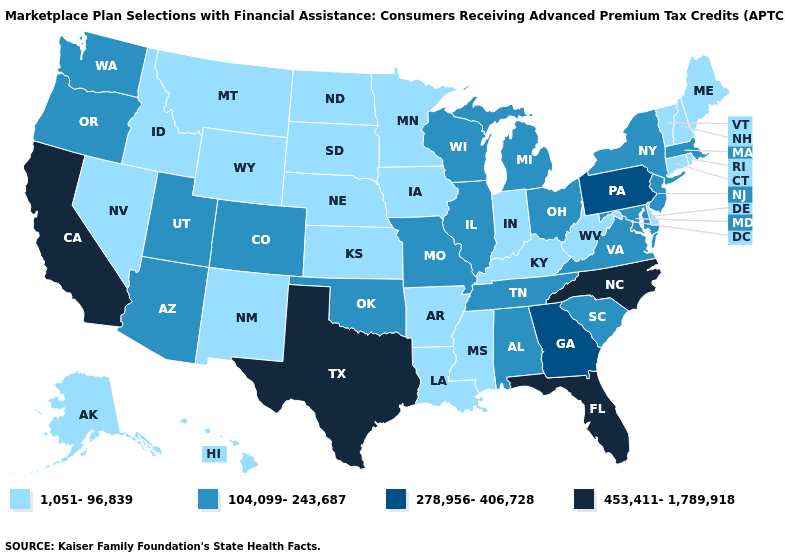What is the value of New York?
Write a very short answer. 104,099-243,687. Does Illinois have the lowest value in the MidWest?
Keep it brief. No. Does Minnesota have a lower value than North Carolina?
Write a very short answer. Yes. What is the highest value in the USA?
Keep it brief. 453,411-1,789,918. Name the states that have a value in the range 453,411-1,789,918?
Write a very short answer. California, Florida, North Carolina, Texas. Does Alabama have the lowest value in the USA?
Keep it brief. No. Does Virginia have the same value as Alabama?
Write a very short answer. Yes. Does Colorado have the highest value in the USA?
Give a very brief answer. No. Name the states that have a value in the range 1,051-96,839?
Concise answer only. Alaska, Arkansas, Connecticut, Delaware, Hawaii, Idaho, Indiana, Iowa, Kansas, Kentucky, Louisiana, Maine, Minnesota, Mississippi, Montana, Nebraska, Nevada, New Hampshire, New Mexico, North Dakota, Rhode Island, South Dakota, Vermont, West Virginia, Wyoming. Which states have the lowest value in the MidWest?
Keep it brief. Indiana, Iowa, Kansas, Minnesota, Nebraska, North Dakota, South Dakota. Name the states that have a value in the range 278,956-406,728?
Be succinct. Georgia, Pennsylvania. Name the states that have a value in the range 453,411-1,789,918?
Be succinct. California, Florida, North Carolina, Texas. Name the states that have a value in the range 104,099-243,687?
Quick response, please. Alabama, Arizona, Colorado, Illinois, Maryland, Massachusetts, Michigan, Missouri, New Jersey, New York, Ohio, Oklahoma, Oregon, South Carolina, Tennessee, Utah, Virginia, Washington, Wisconsin. Does Michigan have the lowest value in the MidWest?
Quick response, please. No. 